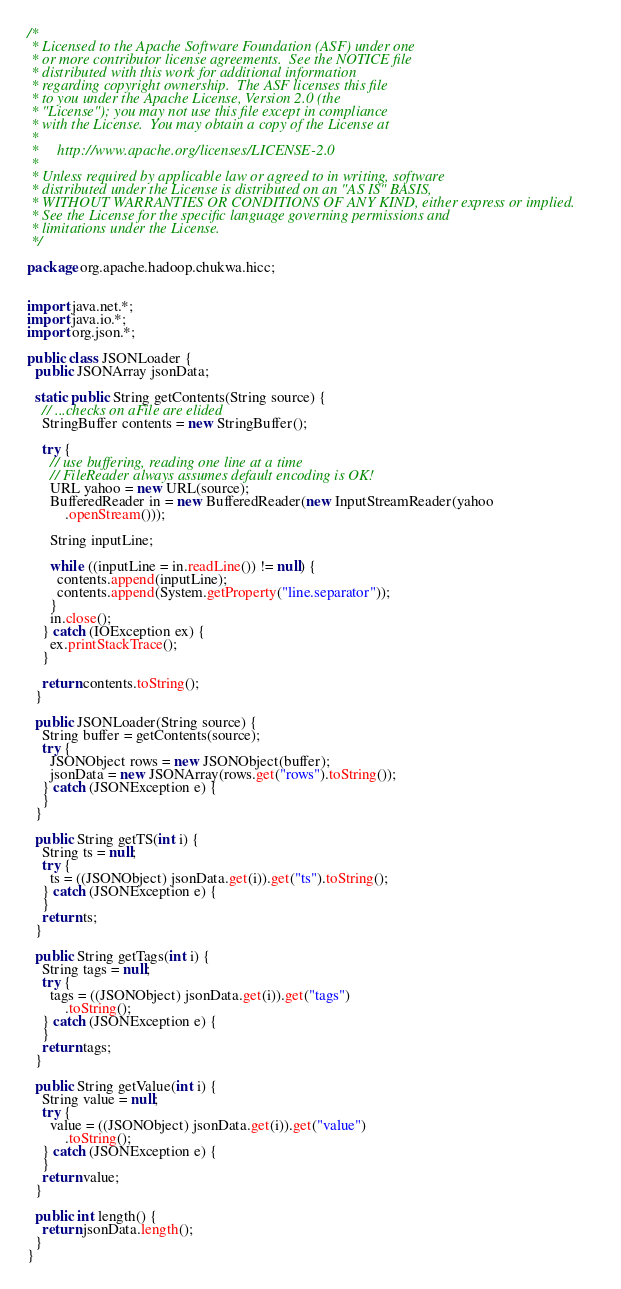<code> <loc_0><loc_0><loc_500><loc_500><_Java_>/*
 * Licensed to the Apache Software Foundation (ASF) under one
 * or more contributor license agreements.  See the NOTICE file
 * distributed with this work for additional information
 * regarding copyright ownership.  The ASF licenses this file
 * to you under the Apache License, Version 2.0 (the
 * "License"); you may not use this file except in compliance
 * with the License.  You may obtain a copy of the License at
 *
 *     http://www.apache.org/licenses/LICENSE-2.0
 *
 * Unless required by applicable law or agreed to in writing, software
 * distributed under the License is distributed on an "AS IS" BASIS,
 * WITHOUT WARRANTIES OR CONDITIONS OF ANY KIND, either express or implied.
 * See the License for the specific language governing permissions and
 * limitations under the License.
 */

package org.apache.hadoop.chukwa.hicc;


import java.net.*;
import java.io.*;
import org.json.*;

public class JSONLoader {
  public JSONArray jsonData;

  static public String getContents(String source) {
    // ...checks on aFile are elided
    StringBuffer contents = new StringBuffer();

    try {
      // use buffering, reading one line at a time
      // FileReader always assumes default encoding is OK!
      URL yahoo = new URL(source);
      BufferedReader in = new BufferedReader(new InputStreamReader(yahoo
          .openStream()));

      String inputLine;

      while ((inputLine = in.readLine()) != null) {
        contents.append(inputLine);
        contents.append(System.getProperty("line.separator"));
      }
      in.close();
    } catch (IOException ex) {
      ex.printStackTrace();
    }

    return contents.toString();
  }

  public JSONLoader(String source) {
    String buffer = getContents(source);
    try {
      JSONObject rows = new JSONObject(buffer);
      jsonData = new JSONArray(rows.get("rows").toString());
    } catch (JSONException e) {
    }
  }

  public String getTS(int i) {
    String ts = null;
    try {
      ts = ((JSONObject) jsonData.get(i)).get("ts").toString();
    } catch (JSONException e) {
    }
    return ts;
  }

  public String getTags(int i) {
    String tags = null;
    try {
      tags = ((JSONObject) jsonData.get(i)).get("tags")
          .toString();
    } catch (JSONException e) {
    }
    return tags;
  }

  public String getValue(int i) {
    String value = null;
    try {
      value = ((JSONObject) jsonData.get(i)).get("value")
          .toString();
    } catch (JSONException e) {
    }
    return value;
  }

  public int length() {
    return jsonData.length();
  }
}
</code> 